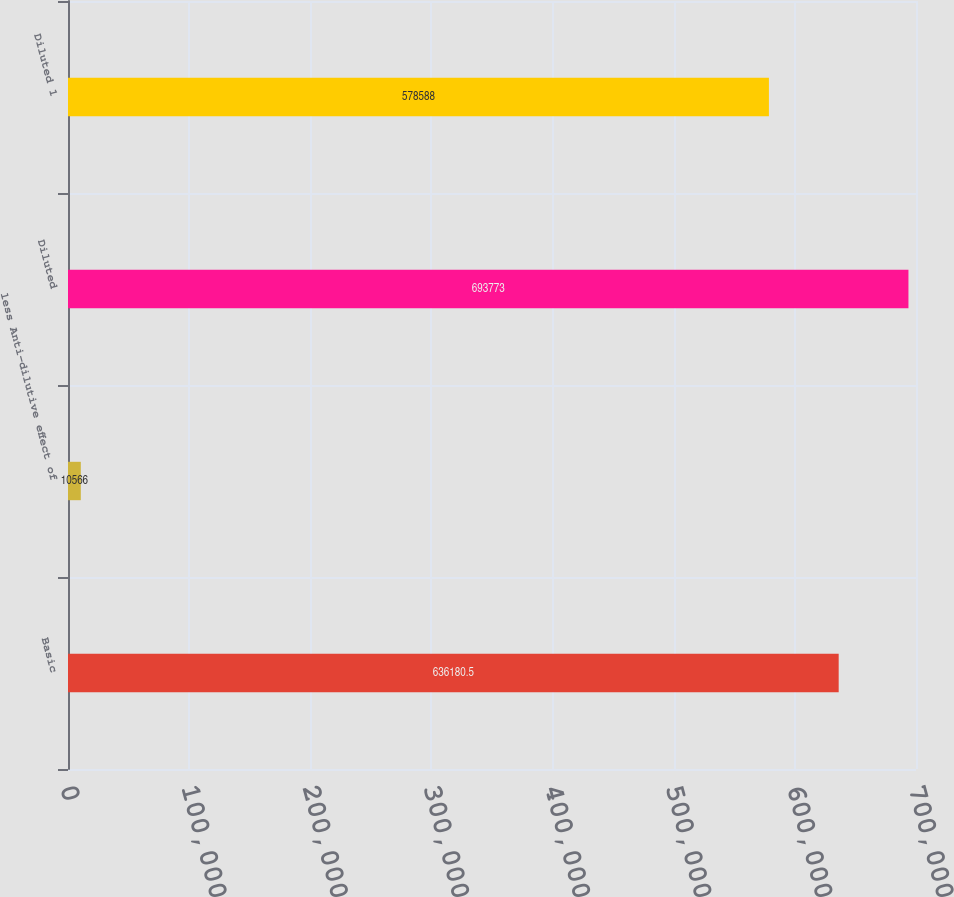Convert chart to OTSL. <chart><loc_0><loc_0><loc_500><loc_500><bar_chart><fcel>Basic<fcel>less Anti-dilutive effect of<fcel>Diluted<fcel>Diluted 1<nl><fcel>636180<fcel>10566<fcel>693773<fcel>578588<nl></chart> 